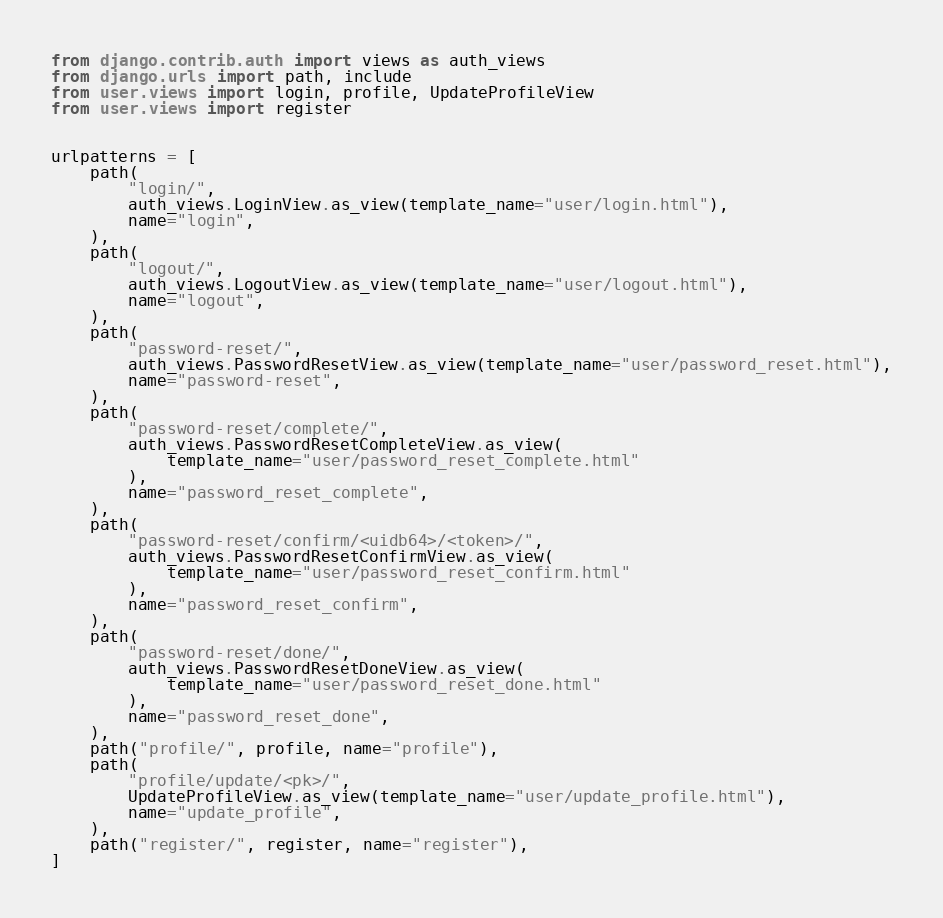Convert code to text. <code><loc_0><loc_0><loc_500><loc_500><_Python_>from django.contrib.auth import views as auth_views
from django.urls import path, include
from user.views import login, profile, UpdateProfileView
from user.views import register


urlpatterns = [
    path(
        "login/",
        auth_views.LoginView.as_view(template_name="user/login.html"),
        name="login",
    ),
    path(
        "logout/",
        auth_views.LogoutView.as_view(template_name="user/logout.html"),
        name="logout",
    ),
    path(
        "password-reset/",
        auth_views.PasswordResetView.as_view(template_name="user/password_reset.html"),
        name="password-reset",
    ),
    path(
        "password-reset/complete/",
        auth_views.PasswordResetCompleteView.as_view(
            template_name="user/password_reset_complete.html"
        ),
        name="password_reset_complete",
    ),
    path(
        "password-reset/confirm/<uidb64>/<token>/",
        auth_views.PasswordResetConfirmView.as_view(
            template_name="user/password_reset_confirm.html"
        ),
        name="password_reset_confirm",
    ),
    path(
        "password-reset/done/",
        auth_views.PasswordResetDoneView.as_view(
            template_name="user/password_reset_done.html"
        ),
        name="password_reset_done",
    ),
    path("profile/", profile, name="profile"),
    path(
        "profile/update/<pk>/",
        UpdateProfileView.as_view(template_name="user/update_profile.html"),
        name="update_profile",
    ),
    path("register/", register, name="register"),
]
</code> 